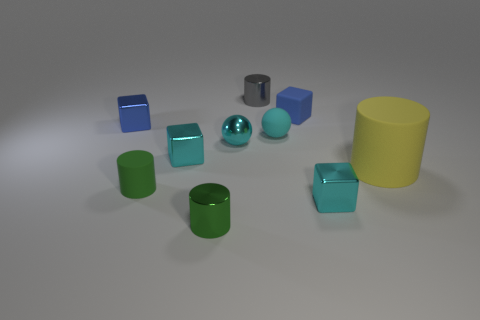Do the small metallic ball and the matte sphere have the same color?
Make the answer very short. Yes. What is the color of the tiny rubber thing that is the same shape as the big object?
Offer a terse response. Green. Is the color of the metal block right of the blue rubber block the same as the small matte sphere?
Make the answer very short. Yes. The thing that is the same color as the tiny rubber block is what shape?
Make the answer very short. Cube. What number of small blue cubes have the same material as the gray object?
Make the answer very short. 1. What number of tiny cyan cubes are to the left of the blue rubber cube?
Your response must be concise. 1. What size is the yellow rubber object?
Provide a short and direct response. Large. There is a matte ball that is the same size as the shiny sphere; what color is it?
Make the answer very short. Cyan. Are there any tiny metal spheres of the same color as the tiny rubber ball?
Provide a succinct answer. Yes. What is the material of the tiny gray cylinder?
Provide a short and direct response. Metal. 